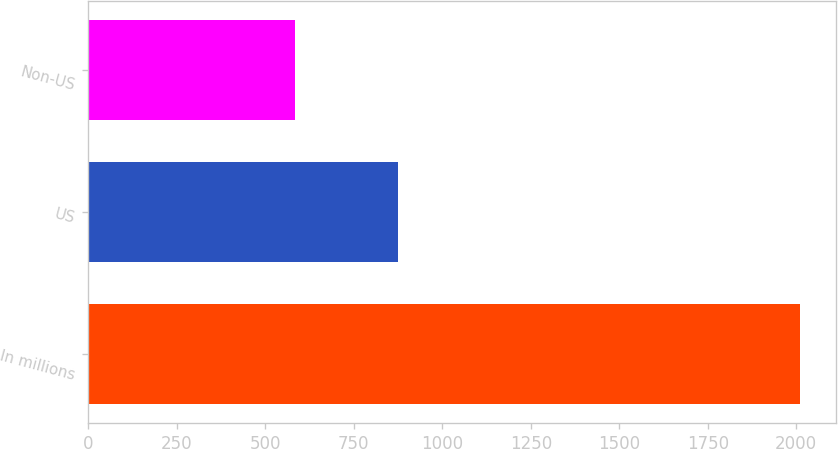<chart> <loc_0><loc_0><loc_500><loc_500><bar_chart><fcel>In millions<fcel>US<fcel>Non-US<nl><fcel>2011<fcel>874<fcel>584<nl></chart> 